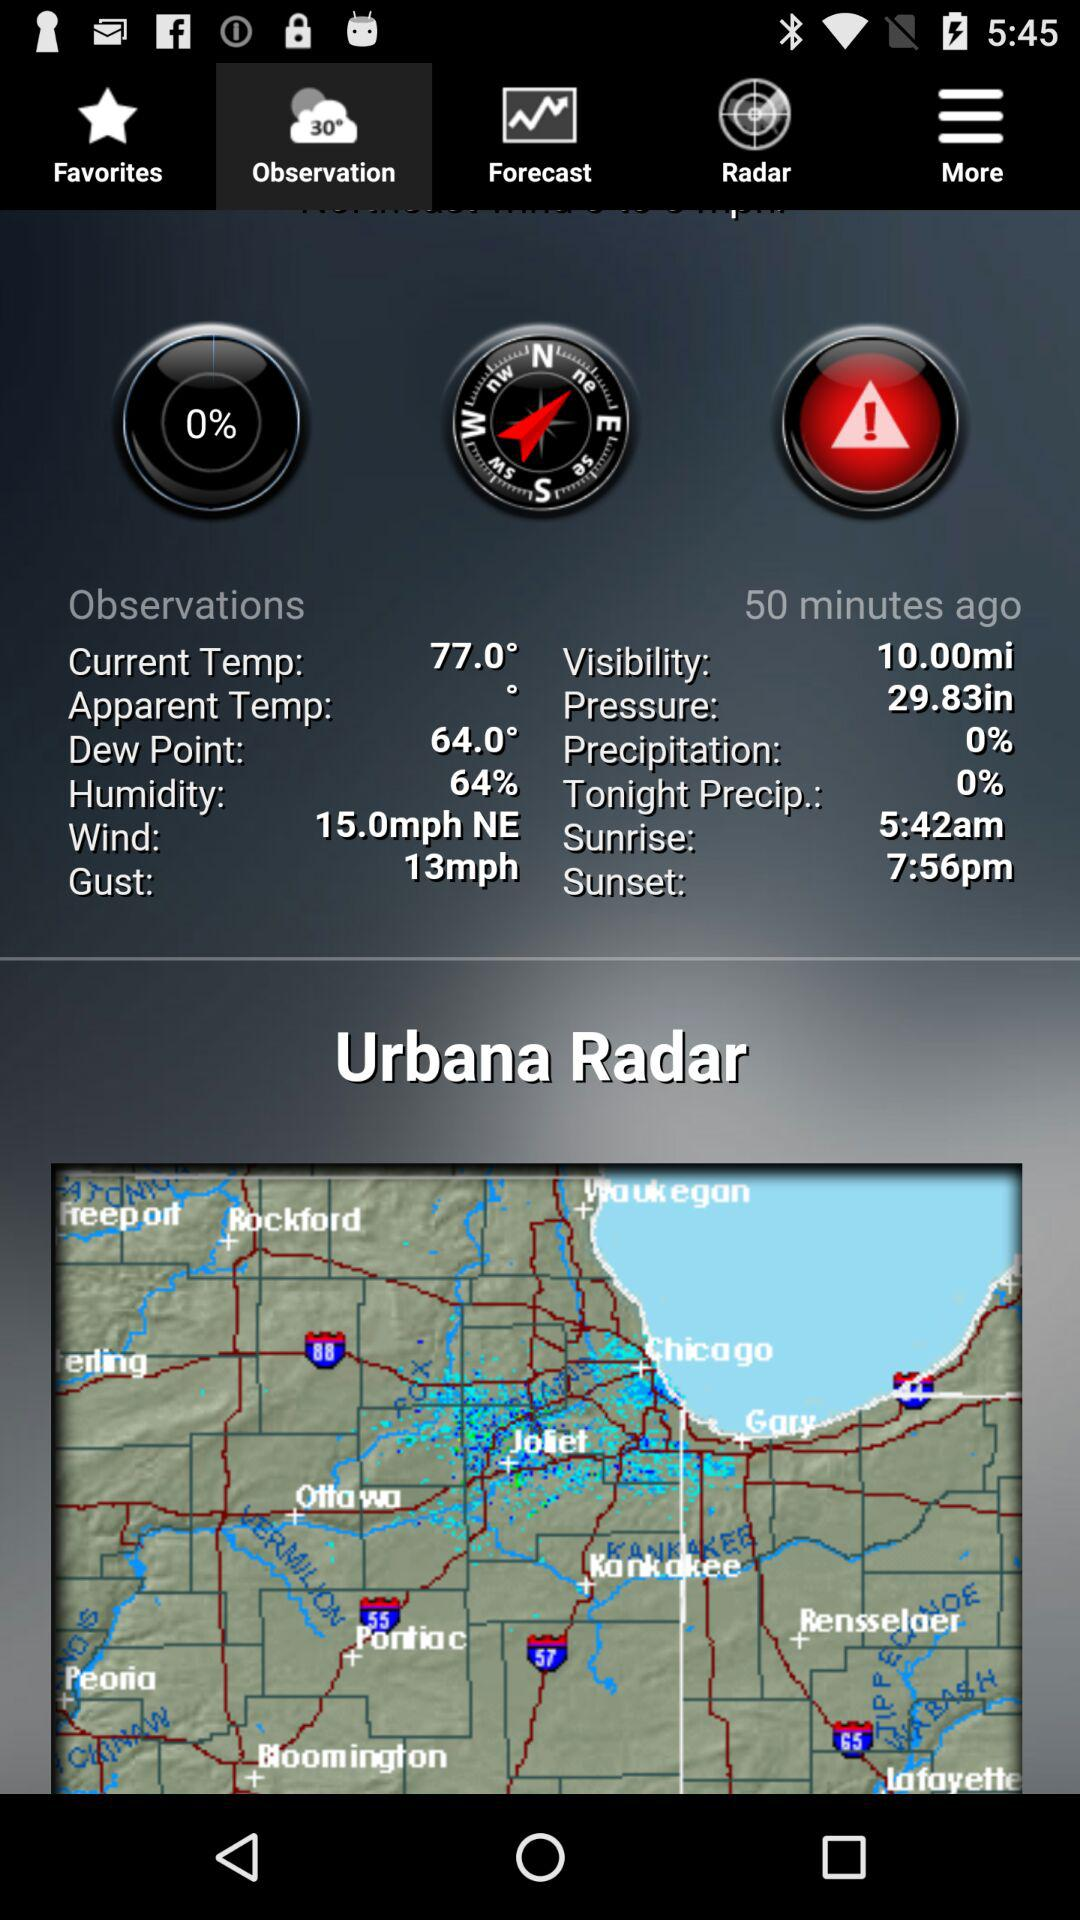What is the wind speed in the current observation?
Answer the question using a single word or phrase. 15.0mph 